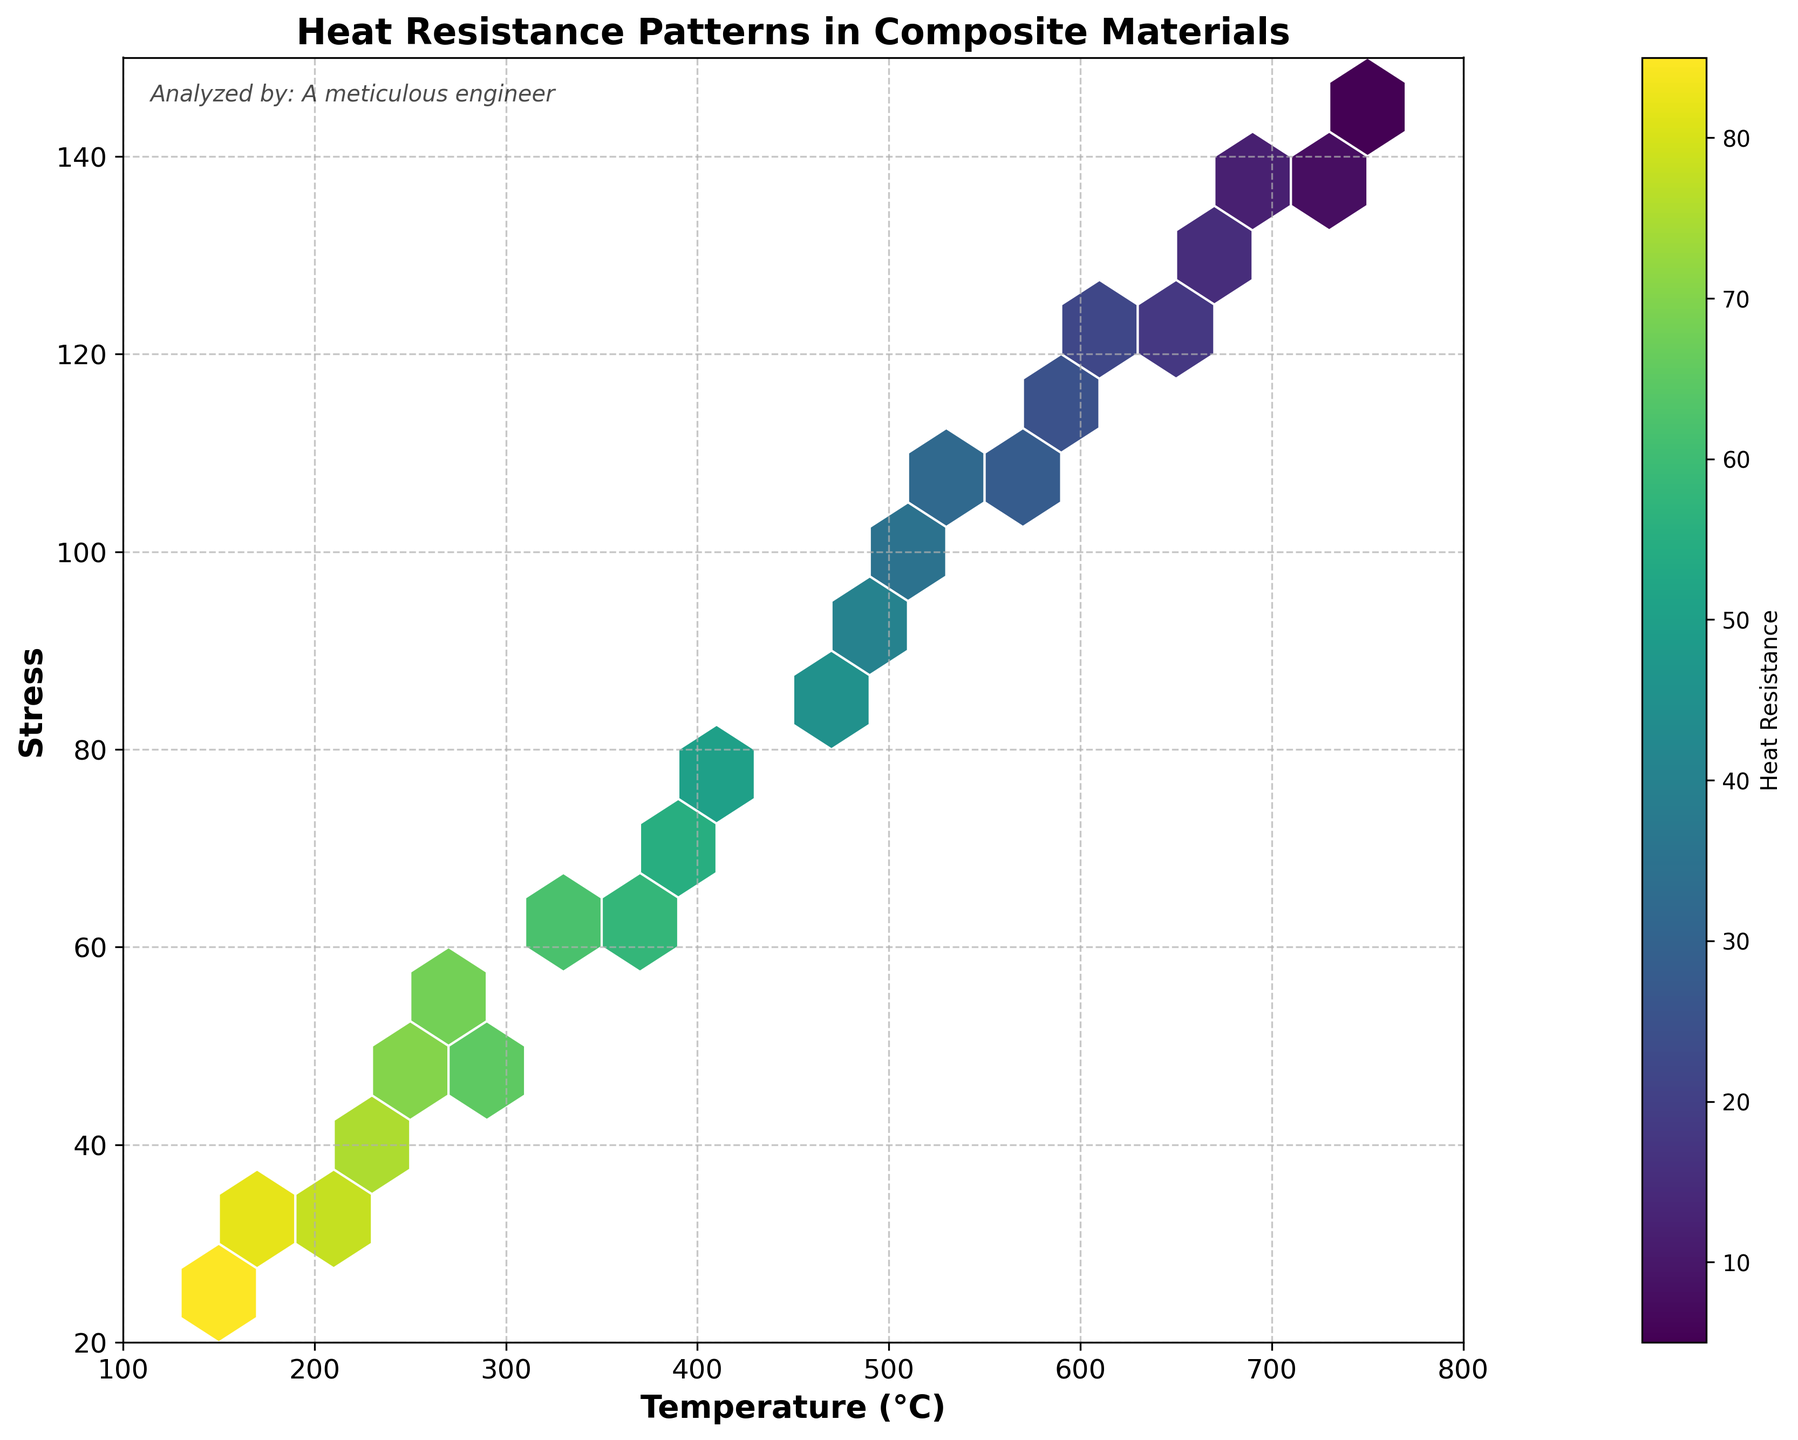What is the title of the figure? The title of the figure is shown at the top center of the plot. It reads "Heat Resistance Patterns in Composite Materials."
Answer: Heat Resistance Patterns in Composite Materials What does the color of the hexagons represent? The color of the hexagons is related to the value of "Heat Resistance," as indicated by the color bar on the right side of the plot. Darker colors denote lower heat resistance, and lighter colors denote higher heat resistance.
Answer: Heat Resistance What range does the x-axis cover? The x-axis, labeled "Temperature (°C)," spans from 100°C to 800°C, as indicated by the axis ticks and the range set by the plot.
Answer: 100°C to 800°C At which temperature and stress level does the highest heat resistance appear? By examining the plot, the lightest-colored hexagons, indicative of the highest heat resistance, are around 150°C temperature and 25 stress units.
Answer: 150°C, 25 How does heat resistance generally change as temperature increases? By observing the color gradient of the hexagons from left to right along the x-axis, the color transitions from lighter to darker, indicating that heat resistance generally decreases as temperature increases.
Answer: Decreases Under which stress condition does heat resistance drop below 50? Looking at the colors corresponding to different stress conditions, heat resistance drops below 50 at approximately 425 stress units and beyond, as shown by the darker colors in the higher stress range.
Answer: 425 What is the general trend between stress and heat resistance? Observing the color of the hexagons along the stress range, the heat resistance generally decreases as stress increases, indicated by the transition from lighter to darker colors.
Answer: Decreases Which has a greater impact on reducing heat resistance, an increase in temperature or stress? By comparing the color intensity along both axes, an increase in temperature seems to have a more pronounced effect on reducing heat resistance as the transition from lighter to darker colors is more significant horizontally (temperature axis) than vertically (stress axis).
Answer: Temperature What is the stress level at a temperature of 550°C with a heat resistance near 30? At 550°C, the hexagon region corresponding to heat resistance near 30 can be identified, which intersects around a stress level of 105.
Answer: 105 Is there any temperature range where heat resistance is particularly high regardless of stress? Examining the x-axis, the range around 150°C to 175°C consistently shows light-colored hexagons, indicating notably high heat resistance irrespective of the stress levels.
Answer: 150°C to 175°C 